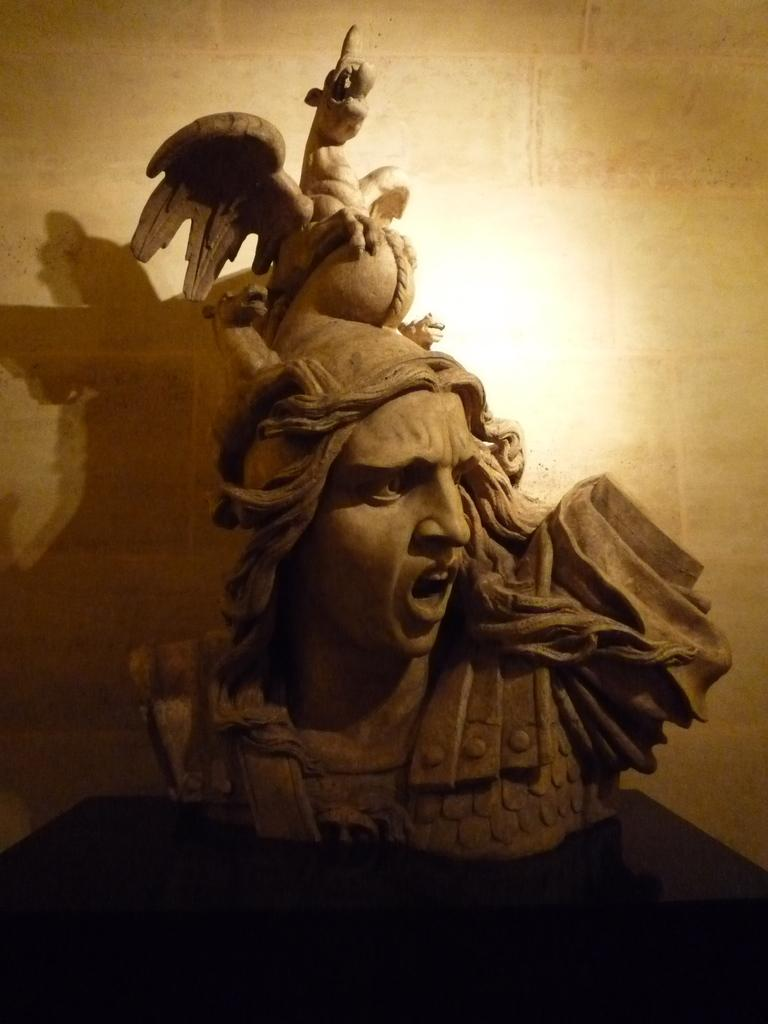What is the main subject in the image? There is a statue in the image. What type of trousers is the statue wearing in the image? The statue is not wearing trousers, as it is a statue and not a person. What kind of haircut does the statue have in the image? The statue does not have a haircut, as it is a statue and not a person. 